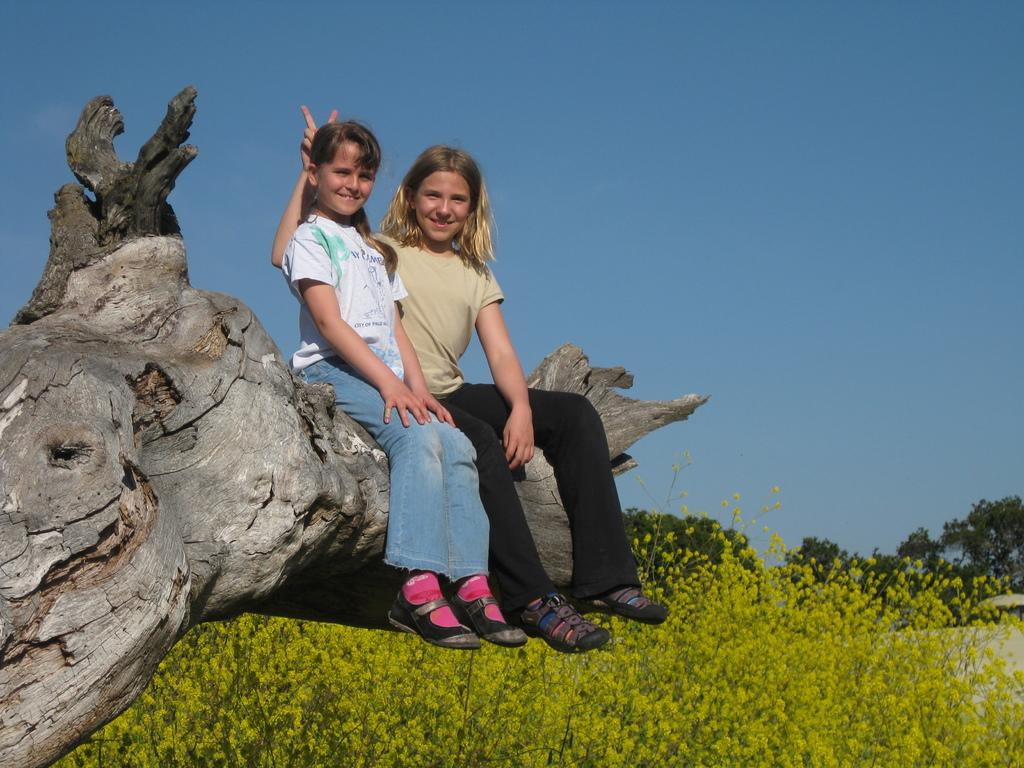How many people are in the image? There are two girls in the image. What are the girls doing in the image? The girls are smiling in the image. Where are the girls sitting? The girls are sitting on a wooden log in the image. What type of vegetation can be seen in the image? There are plants and trees in the image. What is visible in the background of the image? The sky is visible in the background of the image. What type of spy equipment can be seen in the image? There is no spy equipment present in the image. Do the girls have fangs in the image? The girls do not have fangs in the image; they are simply smiling. 